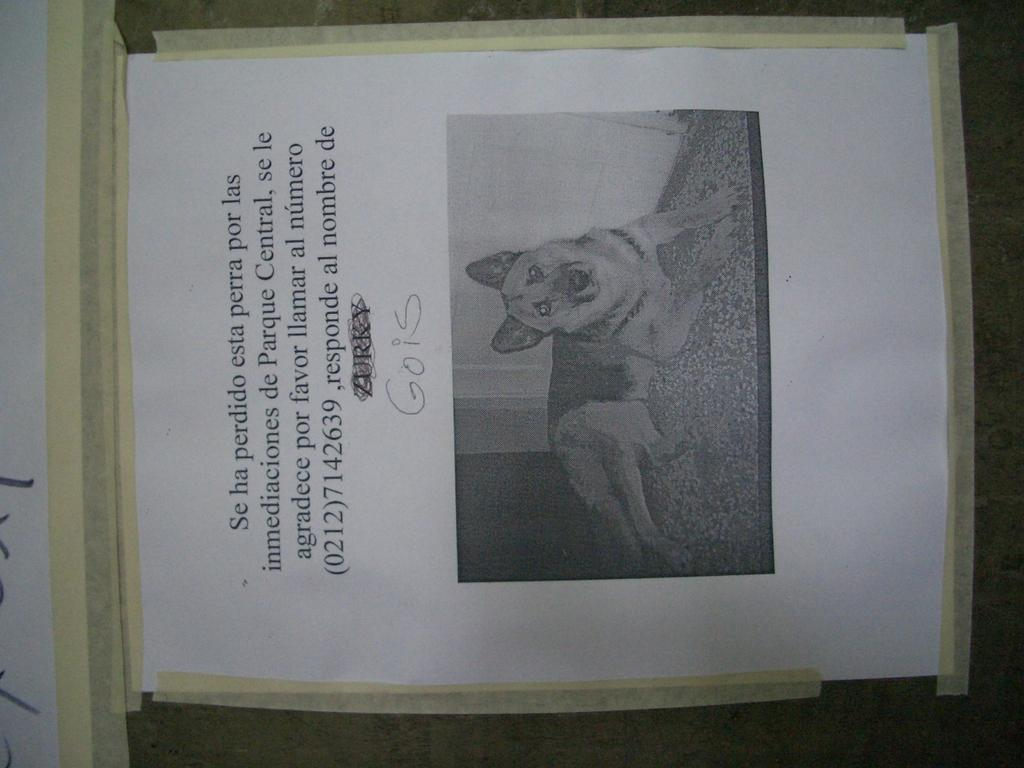What is the main object in the image? There is a board in the image. What is attached to the board? There is a paper attached to the board. What is depicted on the paper? The paper contains a picture of a dog lying on the floor. Is there any text on the paper? Yes, there is text written on the paper. What type of alarm can be heard going off in the image? There is no alarm present in the image, and therefore no sound can be heard. 